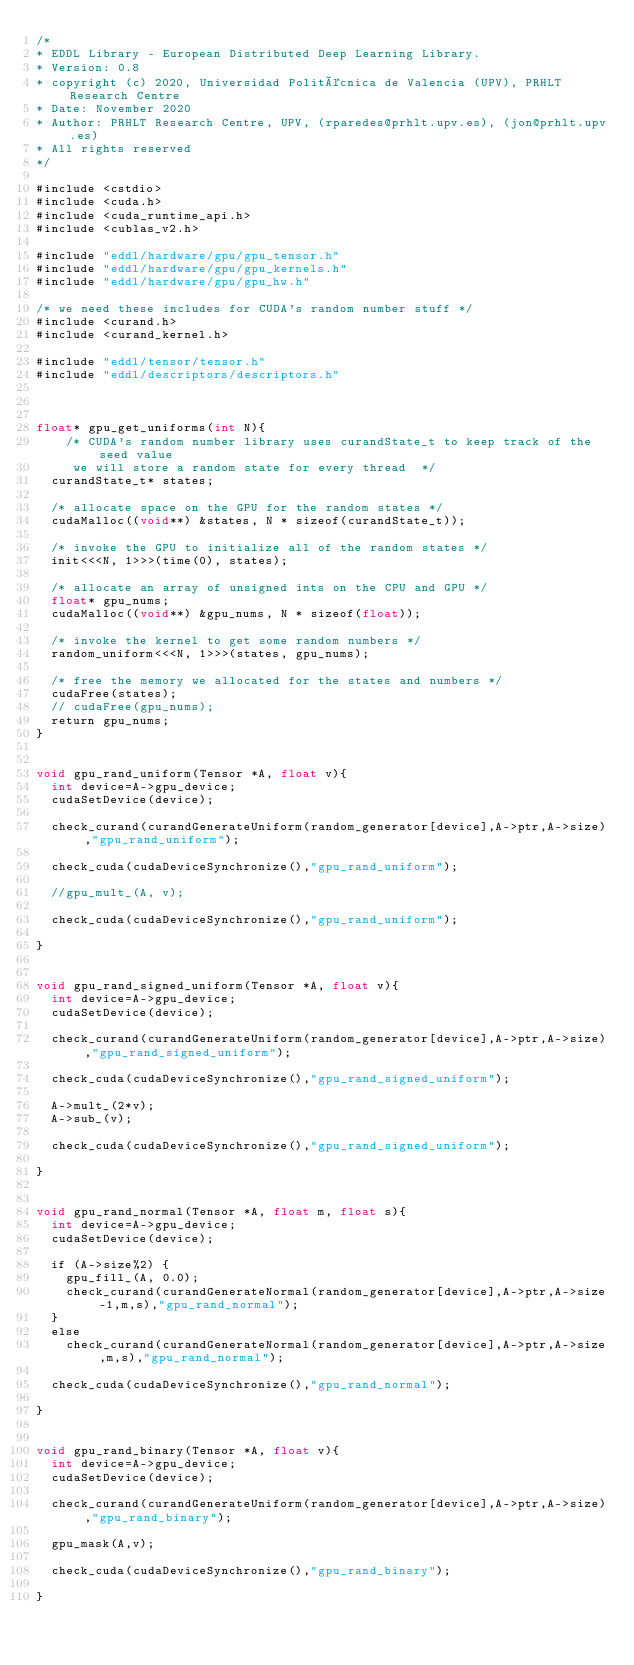<code> <loc_0><loc_0><loc_500><loc_500><_Cuda_>/*
* EDDL Library - European Distributed Deep Learning Library.
* Version: 0.8
* copyright (c) 2020, Universidad Politécnica de Valencia (UPV), PRHLT Research Centre
* Date: November 2020
* Author: PRHLT Research Centre, UPV, (rparedes@prhlt.upv.es), (jon@prhlt.upv.es)
* All rights reserved
*/

#include <cstdio>
#include <cuda.h>
#include <cuda_runtime_api.h>
#include <cublas_v2.h>

#include "eddl/hardware/gpu/gpu_tensor.h"
#include "eddl/hardware/gpu/gpu_kernels.h"
#include "eddl/hardware/gpu/gpu_hw.h"

/* we need these includes for CUDA's random number stuff */
#include <curand.h>
#include <curand_kernel.h>

#include "eddl/tensor/tensor.h"
#include "eddl/descriptors/descriptors.h"



float* gpu_get_uniforms(int N){
    /* CUDA's random number library uses curandState_t to keep track of the seed value
     we will store a random state for every thread  */
  curandState_t* states;

  /* allocate space on the GPU for the random states */
  cudaMalloc((void**) &states, N * sizeof(curandState_t));

  /* invoke the GPU to initialize all of the random states */
  init<<<N, 1>>>(time(0), states);

  /* allocate an array of unsigned ints on the CPU and GPU */
  float* gpu_nums;
  cudaMalloc((void**) &gpu_nums, N * sizeof(float));

  /* invoke the kernel to get some random numbers */
  random_uniform<<<N, 1>>>(states, gpu_nums);

  /* free the memory we allocated for the states and numbers */
  cudaFree(states);
  // cudaFree(gpu_nums);
  return gpu_nums;
}


void gpu_rand_uniform(Tensor *A, float v){
  int device=A->gpu_device;
  cudaSetDevice(device);

  check_curand(curandGenerateUniform(random_generator[device],A->ptr,A->size),"gpu_rand_uniform");

  check_cuda(cudaDeviceSynchronize(),"gpu_rand_uniform");

  //gpu_mult_(A, v);

  check_cuda(cudaDeviceSynchronize(),"gpu_rand_uniform");

}


void gpu_rand_signed_uniform(Tensor *A, float v){
  int device=A->gpu_device;
  cudaSetDevice(device);

  check_curand(curandGenerateUniform(random_generator[device],A->ptr,A->size),"gpu_rand_signed_uniform");

  check_cuda(cudaDeviceSynchronize(),"gpu_rand_signed_uniform");

  A->mult_(2*v);
  A->sub_(v);

  check_cuda(cudaDeviceSynchronize(),"gpu_rand_signed_uniform");

}


void gpu_rand_normal(Tensor *A, float m, float s){
  int device=A->gpu_device;
  cudaSetDevice(device);

  if (A->size%2) {
    gpu_fill_(A, 0.0);
    check_curand(curandGenerateNormal(random_generator[device],A->ptr,A->size-1,m,s),"gpu_rand_normal");
  }
  else
    check_curand(curandGenerateNormal(random_generator[device],A->ptr,A->size,m,s),"gpu_rand_normal");

  check_cuda(cudaDeviceSynchronize(),"gpu_rand_normal");

}


void gpu_rand_binary(Tensor *A, float v){
  int device=A->gpu_device;
  cudaSetDevice(device);

  check_curand(curandGenerateUniform(random_generator[device],A->ptr,A->size),"gpu_rand_binary");

  gpu_mask(A,v);

  check_cuda(cudaDeviceSynchronize(),"gpu_rand_binary");

}
</code> 